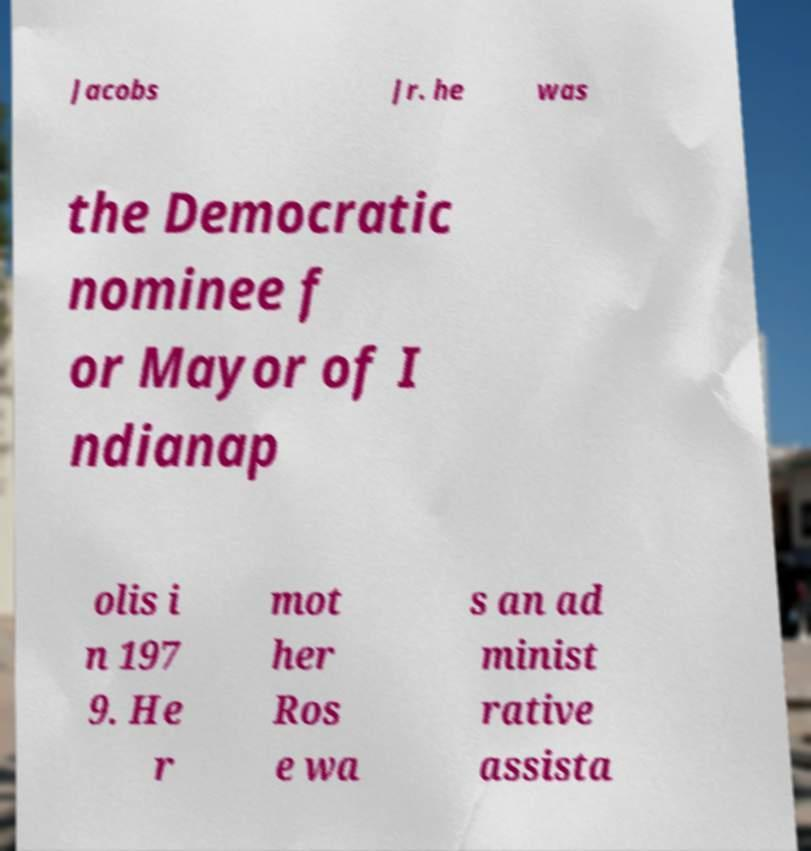For documentation purposes, I need the text within this image transcribed. Could you provide that? Jacobs Jr. he was the Democratic nominee f or Mayor of I ndianap olis i n 197 9. He r mot her Ros e wa s an ad minist rative assista 